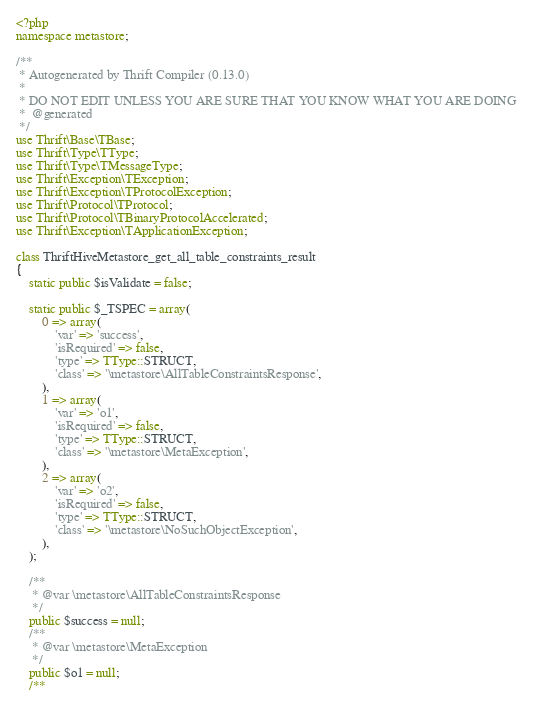<code> <loc_0><loc_0><loc_500><loc_500><_PHP_><?php
namespace metastore;

/**
 * Autogenerated by Thrift Compiler (0.13.0)
 *
 * DO NOT EDIT UNLESS YOU ARE SURE THAT YOU KNOW WHAT YOU ARE DOING
 *  @generated
 */
use Thrift\Base\TBase;
use Thrift\Type\TType;
use Thrift\Type\TMessageType;
use Thrift\Exception\TException;
use Thrift\Exception\TProtocolException;
use Thrift\Protocol\TProtocol;
use Thrift\Protocol\TBinaryProtocolAccelerated;
use Thrift\Exception\TApplicationException;

class ThriftHiveMetastore_get_all_table_constraints_result
{
    static public $isValidate = false;

    static public $_TSPEC = array(
        0 => array(
            'var' => 'success',
            'isRequired' => false,
            'type' => TType::STRUCT,
            'class' => '\metastore\AllTableConstraintsResponse',
        ),
        1 => array(
            'var' => 'o1',
            'isRequired' => false,
            'type' => TType::STRUCT,
            'class' => '\metastore\MetaException',
        ),
        2 => array(
            'var' => 'o2',
            'isRequired' => false,
            'type' => TType::STRUCT,
            'class' => '\metastore\NoSuchObjectException',
        ),
    );

    /**
     * @var \metastore\AllTableConstraintsResponse
     */
    public $success = null;
    /**
     * @var \metastore\MetaException
     */
    public $o1 = null;
    /**</code> 